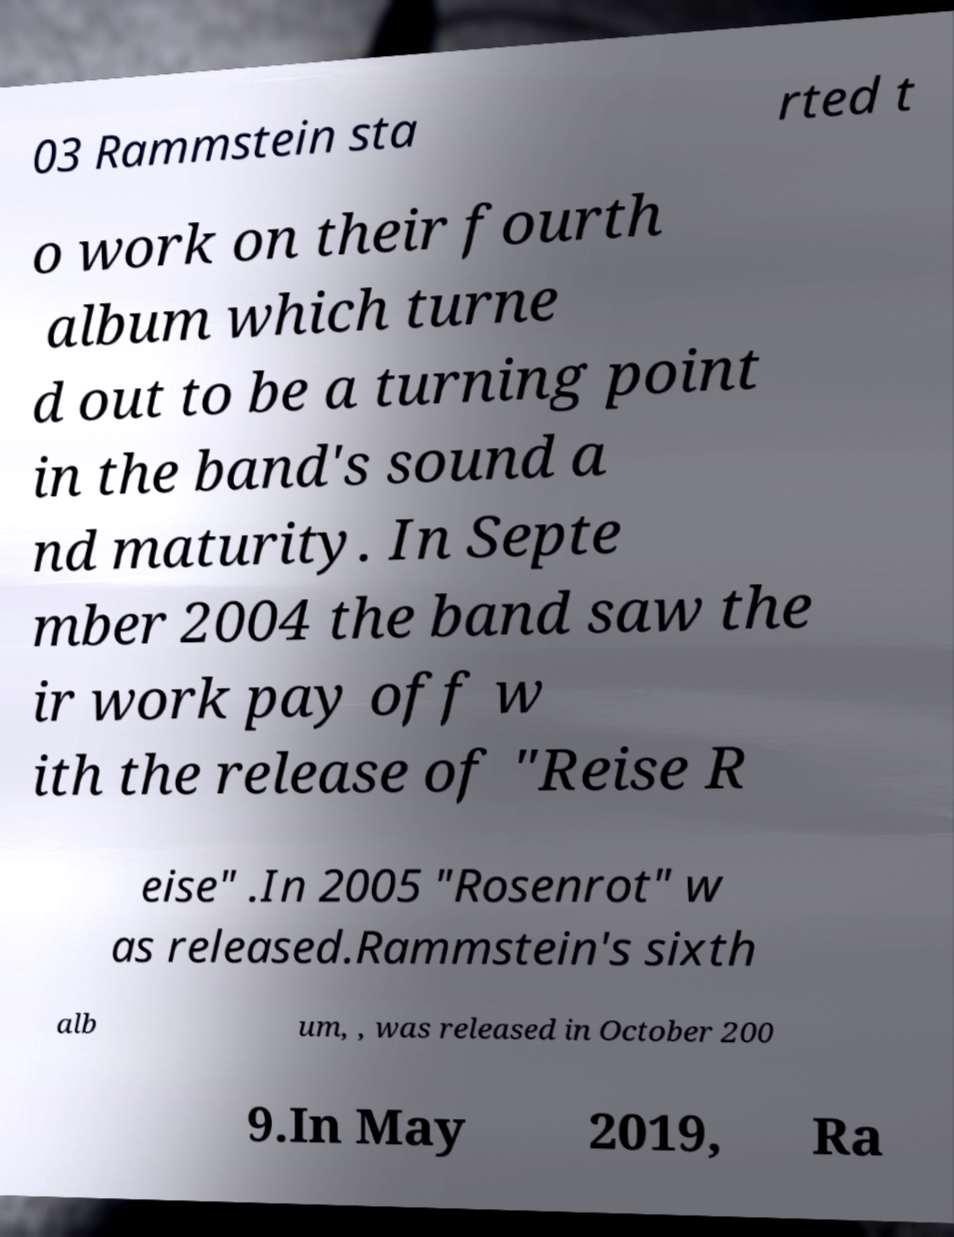Could you assist in decoding the text presented in this image and type it out clearly? 03 Rammstein sta rted t o work on their fourth album which turne d out to be a turning point in the band's sound a nd maturity. In Septe mber 2004 the band saw the ir work pay off w ith the release of "Reise R eise" .In 2005 "Rosenrot" w as released.Rammstein's sixth alb um, , was released in October 200 9.In May 2019, Ra 